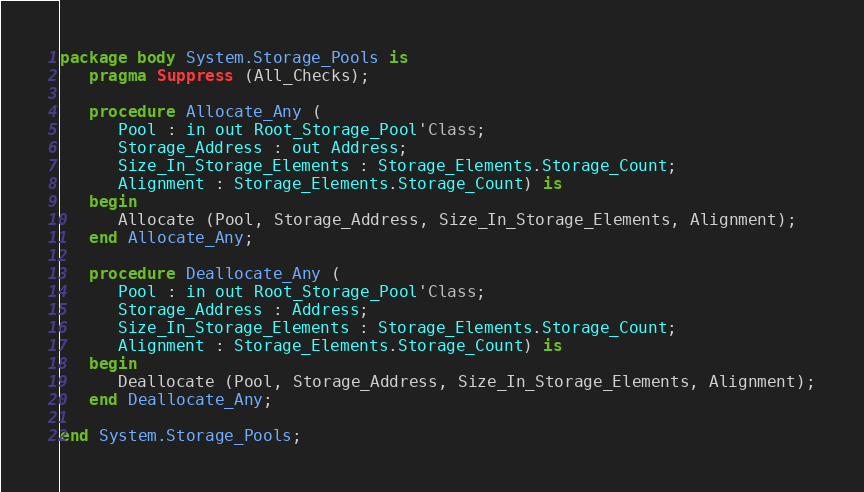Convert code to text. <code><loc_0><loc_0><loc_500><loc_500><_Ada_>package body System.Storage_Pools is
   pragma Suppress (All_Checks);

   procedure Allocate_Any (
      Pool : in out Root_Storage_Pool'Class;
      Storage_Address : out Address;
      Size_In_Storage_Elements : Storage_Elements.Storage_Count;
      Alignment : Storage_Elements.Storage_Count) is
   begin
      Allocate (Pool, Storage_Address, Size_In_Storage_Elements, Alignment);
   end Allocate_Any;

   procedure Deallocate_Any (
      Pool : in out Root_Storage_Pool'Class;
      Storage_Address : Address;
      Size_In_Storage_Elements : Storage_Elements.Storage_Count;
      Alignment : Storage_Elements.Storage_Count) is
   begin
      Deallocate (Pool, Storage_Address, Size_In_Storage_Elements, Alignment);
   end Deallocate_Any;

end System.Storage_Pools;
</code> 